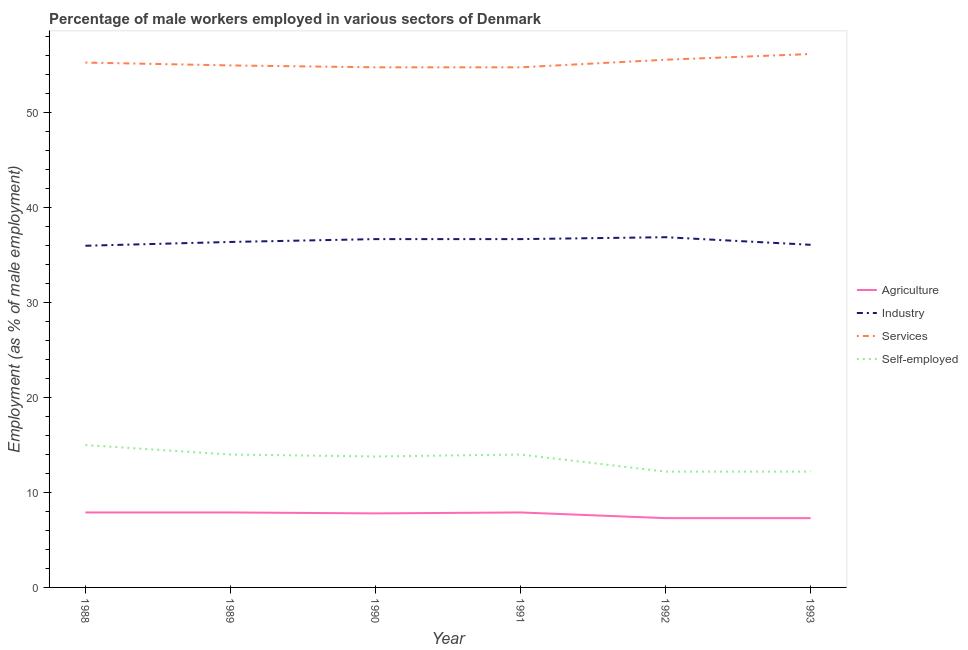Does the line corresponding to percentage of male workers in industry intersect with the line corresponding to percentage of self employed male workers?
Your answer should be very brief. No. What is the percentage of male workers in agriculture in 1993?
Your answer should be very brief. 7.3. Across all years, what is the maximum percentage of male workers in agriculture?
Provide a succinct answer. 7.9. Across all years, what is the minimum percentage of male workers in industry?
Ensure brevity in your answer.  36. In which year was the percentage of male workers in services maximum?
Provide a succinct answer. 1993. In which year was the percentage of male workers in agriculture minimum?
Your response must be concise. 1992. What is the total percentage of male workers in agriculture in the graph?
Your response must be concise. 46.1. What is the difference between the percentage of male workers in services in 1988 and that in 1991?
Offer a very short reply. 0.5. What is the difference between the percentage of male workers in services in 1992 and the percentage of self employed male workers in 1989?
Keep it short and to the point. 41.6. What is the average percentage of male workers in agriculture per year?
Your answer should be compact. 7.68. In the year 1992, what is the difference between the percentage of male workers in agriculture and percentage of male workers in industry?
Offer a terse response. -29.6. What is the ratio of the percentage of male workers in services in 1991 to that in 1992?
Your answer should be very brief. 0.99. Is the difference between the percentage of male workers in agriculture in 1989 and 1993 greater than the difference between the percentage of self employed male workers in 1989 and 1993?
Provide a succinct answer. No. What is the difference between the highest and the second highest percentage of male workers in agriculture?
Offer a very short reply. 0. What is the difference between the highest and the lowest percentage of male workers in agriculture?
Keep it short and to the point. 0.6. In how many years, is the percentage of male workers in industry greater than the average percentage of male workers in industry taken over all years?
Your answer should be compact. 3. Is it the case that in every year, the sum of the percentage of self employed male workers and percentage of male workers in agriculture is greater than the sum of percentage of male workers in services and percentage of male workers in industry?
Offer a terse response. No. Is it the case that in every year, the sum of the percentage of male workers in agriculture and percentage of male workers in industry is greater than the percentage of male workers in services?
Ensure brevity in your answer.  No. Is the percentage of male workers in agriculture strictly greater than the percentage of male workers in industry over the years?
Ensure brevity in your answer.  No. Is the percentage of male workers in industry strictly less than the percentage of male workers in agriculture over the years?
Ensure brevity in your answer.  No. How many years are there in the graph?
Give a very brief answer. 6. What is the difference between two consecutive major ticks on the Y-axis?
Your response must be concise. 10. Are the values on the major ticks of Y-axis written in scientific E-notation?
Offer a very short reply. No. Does the graph contain grids?
Provide a short and direct response. No. How are the legend labels stacked?
Your answer should be very brief. Vertical. What is the title of the graph?
Offer a terse response. Percentage of male workers employed in various sectors of Denmark. Does "Italy" appear as one of the legend labels in the graph?
Your answer should be compact. No. What is the label or title of the Y-axis?
Your response must be concise. Employment (as % of male employment). What is the Employment (as % of male employment) in Agriculture in 1988?
Your answer should be very brief. 7.9. What is the Employment (as % of male employment) of Industry in 1988?
Provide a succinct answer. 36. What is the Employment (as % of male employment) in Services in 1988?
Offer a terse response. 55.3. What is the Employment (as % of male employment) in Agriculture in 1989?
Provide a short and direct response. 7.9. What is the Employment (as % of male employment) of Industry in 1989?
Your answer should be compact. 36.4. What is the Employment (as % of male employment) of Services in 1989?
Your answer should be very brief. 55. What is the Employment (as % of male employment) in Self-employed in 1989?
Ensure brevity in your answer.  14. What is the Employment (as % of male employment) in Agriculture in 1990?
Your answer should be very brief. 7.8. What is the Employment (as % of male employment) in Industry in 1990?
Keep it short and to the point. 36.7. What is the Employment (as % of male employment) in Services in 1990?
Your answer should be very brief. 54.8. What is the Employment (as % of male employment) in Self-employed in 1990?
Give a very brief answer. 13.8. What is the Employment (as % of male employment) of Agriculture in 1991?
Your answer should be very brief. 7.9. What is the Employment (as % of male employment) in Industry in 1991?
Give a very brief answer. 36.7. What is the Employment (as % of male employment) of Services in 1991?
Keep it short and to the point. 54.8. What is the Employment (as % of male employment) of Self-employed in 1991?
Ensure brevity in your answer.  14. What is the Employment (as % of male employment) in Agriculture in 1992?
Offer a terse response. 7.3. What is the Employment (as % of male employment) in Industry in 1992?
Offer a very short reply. 36.9. What is the Employment (as % of male employment) of Services in 1992?
Provide a short and direct response. 55.6. What is the Employment (as % of male employment) of Self-employed in 1992?
Give a very brief answer. 12.2. What is the Employment (as % of male employment) in Agriculture in 1993?
Keep it short and to the point. 7.3. What is the Employment (as % of male employment) of Industry in 1993?
Provide a succinct answer. 36.1. What is the Employment (as % of male employment) in Services in 1993?
Make the answer very short. 56.2. What is the Employment (as % of male employment) of Self-employed in 1993?
Your answer should be compact. 12.2. Across all years, what is the maximum Employment (as % of male employment) in Agriculture?
Keep it short and to the point. 7.9. Across all years, what is the maximum Employment (as % of male employment) of Industry?
Provide a succinct answer. 36.9. Across all years, what is the maximum Employment (as % of male employment) in Services?
Make the answer very short. 56.2. Across all years, what is the maximum Employment (as % of male employment) in Self-employed?
Your answer should be very brief. 15. Across all years, what is the minimum Employment (as % of male employment) of Agriculture?
Offer a terse response. 7.3. Across all years, what is the minimum Employment (as % of male employment) in Services?
Give a very brief answer. 54.8. Across all years, what is the minimum Employment (as % of male employment) of Self-employed?
Your response must be concise. 12.2. What is the total Employment (as % of male employment) in Agriculture in the graph?
Offer a terse response. 46.1. What is the total Employment (as % of male employment) in Industry in the graph?
Make the answer very short. 218.8. What is the total Employment (as % of male employment) of Services in the graph?
Provide a succinct answer. 331.7. What is the total Employment (as % of male employment) of Self-employed in the graph?
Give a very brief answer. 81.2. What is the difference between the Employment (as % of male employment) in Industry in 1988 and that in 1989?
Provide a short and direct response. -0.4. What is the difference between the Employment (as % of male employment) of Self-employed in 1988 and that in 1989?
Offer a terse response. 1. What is the difference between the Employment (as % of male employment) of Agriculture in 1988 and that in 1991?
Offer a terse response. 0. What is the difference between the Employment (as % of male employment) in Services in 1988 and that in 1991?
Offer a terse response. 0.5. What is the difference between the Employment (as % of male employment) of Self-employed in 1988 and that in 1992?
Make the answer very short. 2.8. What is the difference between the Employment (as % of male employment) in Agriculture in 1988 and that in 1993?
Make the answer very short. 0.6. What is the difference between the Employment (as % of male employment) in Industry in 1988 and that in 1993?
Your response must be concise. -0.1. What is the difference between the Employment (as % of male employment) in Services in 1988 and that in 1993?
Keep it short and to the point. -0.9. What is the difference between the Employment (as % of male employment) in Self-employed in 1988 and that in 1993?
Provide a succinct answer. 2.8. What is the difference between the Employment (as % of male employment) of Agriculture in 1989 and that in 1990?
Give a very brief answer. 0.1. What is the difference between the Employment (as % of male employment) in Services in 1989 and that in 1990?
Provide a short and direct response. 0.2. What is the difference between the Employment (as % of male employment) of Industry in 1989 and that in 1991?
Your answer should be compact. -0.3. What is the difference between the Employment (as % of male employment) of Services in 1989 and that in 1991?
Your answer should be very brief. 0.2. What is the difference between the Employment (as % of male employment) of Agriculture in 1989 and that in 1992?
Make the answer very short. 0.6. What is the difference between the Employment (as % of male employment) in Services in 1989 and that in 1992?
Your answer should be very brief. -0.6. What is the difference between the Employment (as % of male employment) in Self-employed in 1989 and that in 1992?
Provide a short and direct response. 1.8. What is the difference between the Employment (as % of male employment) in Agriculture in 1989 and that in 1993?
Keep it short and to the point. 0.6. What is the difference between the Employment (as % of male employment) of Services in 1989 and that in 1993?
Make the answer very short. -1.2. What is the difference between the Employment (as % of male employment) of Industry in 1990 and that in 1991?
Provide a short and direct response. 0. What is the difference between the Employment (as % of male employment) in Services in 1990 and that in 1991?
Offer a very short reply. 0. What is the difference between the Employment (as % of male employment) in Self-employed in 1990 and that in 1991?
Your response must be concise. -0.2. What is the difference between the Employment (as % of male employment) in Industry in 1990 and that in 1992?
Provide a short and direct response. -0.2. What is the difference between the Employment (as % of male employment) in Services in 1990 and that in 1992?
Make the answer very short. -0.8. What is the difference between the Employment (as % of male employment) of Industry in 1990 and that in 1993?
Your answer should be very brief. 0.6. What is the difference between the Employment (as % of male employment) in Services in 1990 and that in 1993?
Provide a short and direct response. -1.4. What is the difference between the Employment (as % of male employment) in Agriculture in 1991 and that in 1992?
Ensure brevity in your answer.  0.6. What is the difference between the Employment (as % of male employment) of Self-employed in 1991 and that in 1992?
Make the answer very short. 1.8. What is the difference between the Employment (as % of male employment) of Self-employed in 1991 and that in 1993?
Your answer should be compact. 1.8. What is the difference between the Employment (as % of male employment) in Agriculture in 1992 and that in 1993?
Ensure brevity in your answer.  0. What is the difference between the Employment (as % of male employment) in Industry in 1992 and that in 1993?
Your answer should be compact. 0.8. What is the difference between the Employment (as % of male employment) in Services in 1992 and that in 1993?
Make the answer very short. -0.6. What is the difference between the Employment (as % of male employment) of Self-employed in 1992 and that in 1993?
Provide a short and direct response. 0. What is the difference between the Employment (as % of male employment) of Agriculture in 1988 and the Employment (as % of male employment) of Industry in 1989?
Offer a very short reply. -28.5. What is the difference between the Employment (as % of male employment) of Agriculture in 1988 and the Employment (as % of male employment) of Services in 1989?
Your response must be concise. -47.1. What is the difference between the Employment (as % of male employment) of Agriculture in 1988 and the Employment (as % of male employment) of Self-employed in 1989?
Provide a succinct answer. -6.1. What is the difference between the Employment (as % of male employment) in Services in 1988 and the Employment (as % of male employment) in Self-employed in 1989?
Your answer should be compact. 41.3. What is the difference between the Employment (as % of male employment) of Agriculture in 1988 and the Employment (as % of male employment) of Industry in 1990?
Ensure brevity in your answer.  -28.8. What is the difference between the Employment (as % of male employment) in Agriculture in 1988 and the Employment (as % of male employment) in Services in 1990?
Ensure brevity in your answer.  -46.9. What is the difference between the Employment (as % of male employment) in Industry in 1988 and the Employment (as % of male employment) in Services in 1990?
Offer a terse response. -18.8. What is the difference between the Employment (as % of male employment) of Industry in 1988 and the Employment (as % of male employment) of Self-employed in 1990?
Your answer should be compact. 22.2. What is the difference between the Employment (as % of male employment) in Services in 1988 and the Employment (as % of male employment) in Self-employed in 1990?
Your answer should be compact. 41.5. What is the difference between the Employment (as % of male employment) in Agriculture in 1988 and the Employment (as % of male employment) in Industry in 1991?
Keep it short and to the point. -28.8. What is the difference between the Employment (as % of male employment) in Agriculture in 1988 and the Employment (as % of male employment) in Services in 1991?
Keep it short and to the point. -46.9. What is the difference between the Employment (as % of male employment) of Agriculture in 1988 and the Employment (as % of male employment) of Self-employed in 1991?
Offer a terse response. -6.1. What is the difference between the Employment (as % of male employment) in Industry in 1988 and the Employment (as % of male employment) in Services in 1991?
Make the answer very short. -18.8. What is the difference between the Employment (as % of male employment) in Industry in 1988 and the Employment (as % of male employment) in Self-employed in 1991?
Provide a succinct answer. 22. What is the difference between the Employment (as % of male employment) of Services in 1988 and the Employment (as % of male employment) of Self-employed in 1991?
Keep it short and to the point. 41.3. What is the difference between the Employment (as % of male employment) of Agriculture in 1988 and the Employment (as % of male employment) of Industry in 1992?
Provide a succinct answer. -29. What is the difference between the Employment (as % of male employment) of Agriculture in 1988 and the Employment (as % of male employment) of Services in 1992?
Offer a terse response. -47.7. What is the difference between the Employment (as % of male employment) of Industry in 1988 and the Employment (as % of male employment) of Services in 1992?
Your answer should be compact. -19.6. What is the difference between the Employment (as % of male employment) in Industry in 1988 and the Employment (as % of male employment) in Self-employed in 1992?
Keep it short and to the point. 23.8. What is the difference between the Employment (as % of male employment) in Services in 1988 and the Employment (as % of male employment) in Self-employed in 1992?
Your answer should be compact. 43.1. What is the difference between the Employment (as % of male employment) of Agriculture in 1988 and the Employment (as % of male employment) of Industry in 1993?
Provide a succinct answer. -28.2. What is the difference between the Employment (as % of male employment) in Agriculture in 1988 and the Employment (as % of male employment) in Services in 1993?
Give a very brief answer. -48.3. What is the difference between the Employment (as % of male employment) in Agriculture in 1988 and the Employment (as % of male employment) in Self-employed in 1993?
Keep it short and to the point. -4.3. What is the difference between the Employment (as % of male employment) of Industry in 1988 and the Employment (as % of male employment) of Services in 1993?
Your response must be concise. -20.2. What is the difference between the Employment (as % of male employment) in Industry in 1988 and the Employment (as % of male employment) in Self-employed in 1993?
Your answer should be compact. 23.8. What is the difference between the Employment (as % of male employment) of Services in 1988 and the Employment (as % of male employment) of Self-employed in 1993?
Your response must be concise. 43.1. What is the difference between the Employment (as % of male employment) in Agriculture in 1989 and the Employment (as % of male employment) in Industry in 1990?
Make the answer very short. -28.8. What is the difference between the Employment (as % of male employment) of Agriculture in 1989 and the Employment (as % of male employment) of Services in 1990?
Keep it short and to the point. -46.9. What is the difference between the Employment (as % of male employment) in Agriculture in 1989 and the Employment (as % of male employment) in Self-employed in 1990?
Keep it short and to the point. -5.9. What is the difference between the Employment (as % of male employment) of Industry in 1989 and the Employment (as % of male employment) of Services in 1990?
Offer a terse response. -18.4. What is the difference between the Employment (as % of male employment) of Industry in 1989 and the Employment (as % of male employment) of Self-employed in 1990?
Your response must be concise. 22.6. What is the difference between the Employment (as % of male employment) in Services in 1989 and the Employment (as % of male employment) in Self-employed in 1990?
Make the answer very short. 41.2. What is the difference between the Employment (as % of male employment) in Agriculture in 1989 and the Employment (as % of male employment) in Industry in 1991?
Ensure brevity in your answer.  -28.8. What is the difference between the Employment (as % of male employment) in Agriculture in 1989 and the Employment (as % of male employment) in Services in 1991?
Provide a short and direct response. -46.9. What is the difference between the Employment (as % of male employment) of Agriculture in 1989 and the Employment (as % of male employment) of Self-employed in 1991?
Keep it short and to the point. -6.1. What is the difference between the Employment (as % of male employment) in Industry in 1989 and the Employment (as % of male employment) in Services in 1991?
Keep it short and to the point. -18.4. What is the difference between the Employment (as % of male employment) in Industry in 1989 and the Employment (as % of male employment) in Self-employed in 1991?
Your response must be concise. 22.4. What is the difference between the Employment (as % of male employment) of Services in 1989 and the Employment (as % of male employment) of Self-employed in 1991?
Keep it short and to the point. 41. What is the difference between the Employment (as % of male employment) of Agriculture in 1989 and the Employment (as % of male employment) of Services in 1992?
Your answer should be very brief. -47.7. What is the difference between the Employment (as % of male employment) of Agriculture in 1989 and the Employment (as % of male employment) of Self-employed in 1992?
Offer a very short reply. -4.3. What is the difference between the Employment (as % of male employment) of Industry in 1989 and the Employment (as % of male employment) of Services in 1992?
Keep it short and to the point. -19.2. What is the difference between the Employment (as % of male employment) of Industry in 1989 and the Employment (as % of male employment) of Self-employed in 1992?
Your answer should be compact. 24.2. What is the difference between the Employment (as % of male employment) in Services in 1989 and the Employment (as % of male employment) in Self-employed in 1992?
Offer a very short reply. 42.8. What is the difference between the Employment (as % of male employment) of Agriculture in 1989 and the Employment (as % of male employment) of Industry in 1993?
Provide a succinct answer. -28.2. What is the difference between the Employment (as % of male employment) in Agriculture in 1989 and the Employment (as % of male employment) in Services in 1993?
Provide a succinct answer. -48.3. What is the difference between the Employment (as % of male employment) in Agriculture in 1989 and the Employment (as % of male employment) in Self-employed in 1993?
Your answer should be very brief. -4.3. What is the difference between the Employment (as % of male employment) of Industry in 1989 and the Employment (as % of male employment) of Services in 1993?
Give a very brief answer. -19.8. What is the difference between the Employment (as % of male employment) of Industry in 1989 and the Employment (as % of male employment) of Self-employed in 1993?
Ensure brevity in your answer.  24.2. What is the difference between the Employment (as % of male employment) in Services in 1989 and the Employment (as % of male employment) in Self-employed in 1993?
Provide a succinct answer. 42.8. What is the difference between the Employment (as % of male employment) in Agriculture in 1990 and the Employment (as % of male employment) in Industry in 1991?
Ensure brevity in your answer.  -28.9. What is the difference between the Employment (as % of male employment) of Agriculture in 1990 and the Employment (as % of male employment) of Services in 1991?
Your answer should be compact. -47. What is the difference between the Employment (as % of male employment) of Agriculture in 1990 and the Employment (as % of male employment) of Self-employed in 1991?
Make the answer very short. -6.2. What is the difference between the Employment (as % of male employment) of Industry in 1990 and the Employment (as % of male employment) of Services in 1991?
Provide a short and direct response. -18.1. What is the difference between the Employment (as % of male employment) in Industry in 1990 and the Employment (as % of male employment) in Self-employed in 1991?
Provide a succinct answer. 22.7. What is the difference between the Employment (as % of male employment) in Services in 1990 and the Employment (as % of male employment) in Self-employed in 1991?
Offer a terse response. 40.8. What is the difference between the Employment (as % of male employment) in Agriculture in 1990 and the Employment (as % of male employment) in Industry in 1992?
Ensure brevity in your answer.  -29.1. What is the difference between the Employment (as % of male employment) in Agriculture in 1990 and the Employment (as % of male employment) in Services in 1992?
Make the answer very short. -47.8. What is the difference between the Employment (as % of male employment) in Agriculture in 1990 and the Employment (as % of male employment) in Self-employed in 1992?
Your answer should be very brief. -4.4. What is the difference between the Employment (as % of male employment) of Industry in 1990 and the Employment (as % of male employment) of Services in 1992?
Your answer should be compact. -18.9. What is the difference between the Employment (as % of male employment) in Industry in 1990 and the Employment (as % of male employment) in Self-employed in 1992?
Keep it short and to the point. 24.5. What is the difference between the Employment (as % of male employment) in Services in 1990 and the Employment (as % of male employment) in Self-employed in 1992?
Provide a succinct answer. 42.6. What is the difference between the Employment (as % of male employment) in Agriculture in 1990 and the Employment (as % of male employment) in Industry in 1993?
Provide a succinct answer. -28.3. What is the difference between the Employment (as % of male employment) in Agriculture in 1990 and the Employment (as % of male employment) in Services in 1993?
Make the answer very short. -48.4. What is the difference between the Employment (as % of male employment) in Industry in 1990 and the Employment (as % of male employment) in Services in 1993?
Give a very brief answer. -19.5. What is the difference between the Employment (as % of male employment) of Industry in 1990 and the Employment (as % of male employment) of Self-employed in 1993?
Your answer should be compact. 24.5. What is the difference between the Employment (as % of male employment) of Services in 1990 and the Employment (as % of male employment) of Self-employed in 1993?
Provide a succinct answer. 42.6. What is the difference between the Employment (as % of male employment) in Agriculture in 1991 and the Employment (as % of male employment) in Services in 1992?
Ensure brevity in your answer.  -47.7. What is the difference between the Employment (as % of male employment) in Industry in 1991 and the Employment (as % of male employment) in Services in 1992?
Provide a succinct answer. -18.9. What is the difference between the Employment (as % of male employment) in Industry in 1991 and the Employment (as % of male employment) in Self-employed in 1992?
Your answer should be compact. 24.5. What is the difference between the Employment (as % of male employment) in Services in 1991 and the Employment (as % of male employment) in Self-employed in 1992?
Keep it short and to the point. 42.6. What is the difference between the Employment (as % of male employment) in Agriculture in 1991 and the Employment (as % of male employment) in Industry in 1993?
Your answer should be very brief. -28.2. What is the difference between the Employment (as % of male employment) of Agriculture in 1991 and the Employment (as % of male employment) of Services in 1993?
Provide a short and direct response. -48.3. What is the difference between the Employment (as % of male employment) of Agriculture in 1991 and the Employment (as % of male employment) of Self-employed in 1993?
Your response must be concise. -4.3. What is the difference between the Employment (as % of male employment) of Industry in 1991 and the Employment (as % of male employment) of Services in 1993?
Your answer should be very brief. -19.5. What is the difference between the Employment (as % of male employment) in Services in 1991 and the Employment (as % of male employment) in Self-employed in 1993?
Ensure brevity in your answer.  42.6. What is the difference between the Employment (as % of male employment) in Agriculture in 1992 and the Employment (as % of male employment) in Industry in 1993?
Offer a terse response. -28.8. What is the difference between the Employment (as % of male employment) in Agriculture in 1992 and the Employment (as % of male employment) in Services in 1993?
Your answer should be compact. -48.9. What is the difference between the Employment (as % of male employment) of Agriculture in 1992 and the Employment (as % of male employment) of Self-employed in 1993?
Your response must be concise. -4.9. What is the difference between the Employment (as % of male employment) in Industry in 1992 and the Employment (as % of male employment) in Services in 1993?
Ensure brevity in your answer.  -19.3. What is the difference between the Employment (as % of male employment) of Industry in 1992 and the Employment (as % of male employment) of Self-employed in 1993?
Keep it short and to the point. 24.7. What is the difference between the Employment (as % of male employment) of Services in 1992 and the Employment (as % of male employment) of Self-employed in 1993?
Provide a short and direct response. 43.4. What is the average Employment (as % of male employment) in Agriculture per year?
Your answer should be very brief. 7.68. What is the average Employment (as % of male employment) in Industry per year?
Your answer should be compact. 36.47. What is the average Employment (as % of male employment) of Services per year?
Your answer should be compact. 55.28. What is the average Employment (as % of male employment) of Self-employed per year?
Ensure brevity in your answer.  13.53. In the year 1988, what is the difference between the Employment (as % of male employment) of Agriculture and Employment (as % of male employment) of Industry?
Provide a short and direct response. -28.1. In the year 1988, what is the difference between the Employment (as % of male employment) of Agriculture and Employment (as % of male employment) of Services?
Provide a succinct answer. -47.4. In the year 1988, what is the difference between the Employment (as % of male employment) of Agriculture and Employment (as % of male employment) of Self-employed?
Offer a very short reply. -7.1. In the year 1988, what is the difference between the Employment (as % of male employment) in Industry and Employment (as % of male employment) in Services?
Your answer should be compact. -19.3. In the year 1988, what is the difference between the Employment (as % of male employment) of Industry and Employment (as % of male employment) of Self-employed?
Offer a terse response. 21. In the year 1988, what is the difference between the Employment (as % of male employment) of Services and Employment (as % of male employment) of Self-employed?
Give a very brief answer. 40.3. In the year 1989, what is the difference between the Employment (as % of male employment) of Agriculture and Employment (as % of male employment) of Industry?
Your answer should be very brief. -28.5. In the year 1989, what is the difference between the Employment (as % of male employment) of Agriculture and Employment (as % of male employment) of Services?
Provide a succinct answer. -47.1. In the year 1989, what is the difference between the Employment (as % of male employment) of Agriculture and Employment (as % of male employment) of Self-employed?
Your response must be concise. -6.1. In the year 1989, what is the difference between the Employment (as % of male employment) in Industry and Employment (as % of male employment) in Services?
Provide a succinct answer. -18.6. In the year 1989, what is the difference between the Employment (as % of male employment) of Industry and Employment (as % of male employment) of Self-employed?
Keep it short and to the point. 22.4. In the year 1990, what is the difference between the Employment (as % of male employment) of Agriculture and Employment (as % of male employment) of Industry?
Your answer should be compact. -28.9. In the year 1990, what is the difference between the Employment (as % of male employment) of Agriculture and Employment (as % of male employment) of Services?
Your response must be concise. -47. In the year 1990, what is the difference between the Employment (as % of male employment) in Agriculture and Employment (as % of male employment) in Self-employed?
Offer a terse response. -6. In the year 1990, what is the difference between the Employment (as % of male employment) in Industry and Employment (as % of male employment) in Services?
Keep it short and to the point. -18.1. In the year 1990, what is the difference between the Employment (as % of male employment) of Industry and Employment (as % of male employment) of Self-employed?
Make the answer very short. 22.9. In the year 1991, what is the difference between the Employment (as % of male employment) in Agriculture and Employment (as % of male employment) in Industry?
Your answer should be compact. -28.8. In the year 1991, what is the difference between the Employment (as % of male employment) of Agriculture and Employment (as % of male employment) of Services?
Offer a very short reply. -46.9. In the year 1991, what is the difference between the Employment (as % of male employment) in Industry and Employment (as % of male employment) in Services?
Give a very brief answer. -18.1. In the year 1991, what is the difference between the Employment (as % of male employment) of Industry and Employment (as % of male employment) of Self-employed?
Ensure brevity in your answer.  22.7. In the year 1991, what is the difference between the Employment (as % of male employment) of Services and Employment (as % of male employment) of Self-employed?
Your response must be concise. 40.8. In the year 1992, what is the difference between the Employment (as % of male employment) of Agriculture and Employment (as % of male employment) of Industry?
Your answer should be compact. -29.6. In the year 1992, what is the difference between the Employment (as % of male employment) in Agriculture and Employment (as % of male employment) in Services?
Ensure brevity in your answer.  -48.3. In the year 1992, what is the difference between the Employment (as % of male employment) in Industry and Employment (as % of male employment) in Services?
Your answer should be very brief. -18.7. In the year 1992, what is the difference between the Employment (as % of male employment) in Industry and Employment (as % of male employment) in Self-employed?
Your response must be concise. 24.7. In the year 1992, what is the difference between the Employment (as % of male employment) in Services and Employment (as % of male employment) in Self-employed?
Provide a short and direct response. 43.4. In the year 1993, what is the difference between the Employment (as % of male employment) of Agriculture and Employment (as % of male employment) of Industry?
Offer a terse response. -28.8. In the year 1993, what is the difference between the Employment (as % of male employment) in Agriculture and Employment (as % of male employment) in Services?
Keep it short and to the point. -48.9. In the year 1993, what is the difference between the Employment (as % of male employment) of Agriculture and Employment (as % of male employment) of Self-employed?
Your response must be concise. -4.9. In the year 1993, what is the difference between the Employment (as % of male employment) in Industry and Employment (as % of male employment) in Services?
Offer a terse response. -20.1. In the year 1993, what is the difference between the Employment (as % of male employment) in Industry and Employment (as % of male employment) in Self-employed?
Ensure brevity in your answer.  23.9. In the year 1993, what is the difference between the Employment (as % of male employment) in Services and Employment (as % of male employment) in Self-employed?
Offer a terse response. 44. What is the ratio of the Employment (as % of male employment) in Industry in 1988 to that in 1989?
Your answer should be very brief. 0.99. What is the ratio of the Employment (as % of male employment) in Services in 1988 to that in 1989?
Your answer should be compact. 1.01. What is the ratio of the Employment (as % of male employment) in Self-employed in 1988 to that in 1989?
Your response must be concise. 1.07. What is the ratio of the Employment (as % of male employment) in Agriculture in 1988 to that in 1990?
Offer a terse response. 1.01. What is the ratio of the Employment (as % of male employment) of Industry in 1988 to that in 1990?
Your answer should be compact. 0.98. What is the ratio of the Employment (as % of male employment) of Services in 1988 to that in 1990?
Offer a terse response. 1.01. What is the ratio of the Employment (as % of male employment) in Self-employed in 1988 to that in 1990?
Provide a succinct answer. 1.09. What is the ratio of the Employment (as % of male employment) in Agriculture in 1988 to that in 1991?
Give a very brief answer. 1. What is the ratio of the Employment (as % of male employment) in Industry in 1988 to that in 1991?
Provide a succinct answer. 0.98. What is the ratio of the Employment (as % of male employment) in Services in 1988 to that in 1991?
Give a very brief answer. 1.01. What is the ratio of the Employment (as % of male employment) in Self-employed in 1988 to that in 1991?
Your response must be concise. 1.07. What is the ratio of the Employment (as % of male employment) in Agriculture in 1988 to that in 1992?
Your answer should be very brief. 1.08. What is the ratio of the Employment (as % of male employment) of Industry in 1988 to that in 1992?
Give a very brief answer. 0.98. What is the ratio of the Employment (as % of male employment) in Self-employed in 1988 to that in 1992?
Make the answer very short. 1.23. What is the ratio of the Employment (as % of male employment) in Agriculture in 1988 to that in 1993?
Provide a short and direct response. 1.08. What is the ratio of the Employment (as % of male employment) in Self-employed in 1988 to that in 1993?
Keep it short and to the point. 1.23. What is the ratio of the Employment (as % of male employment) in Agriculture in 1989 to that in 1990?
Keep it short and to the point. 1.01. What is the ratio of the Employment (as % of male employment) in Services in 1989 to that in 1990?
Keep it short and to the point. 1. What is the ratio of the Employment (as % of male employment) of Self-employed in 1989 to that in 1990?
Your response must be concise. 1.01. What is the ratio of the Employment (as % of male employment) of Self-employed in 1989 to that in 1991?
Your response must be concise. 1. What is the ratio of the Employment (as % of male employment) of Agriculture in 1989 to that in 1992?
Make the answer very short. 1.08. What is the ratio of the Employment (as % of male employment) in Industry in 1989 to that in 1992?
Ensure brevity in your answer.  0.99. What is the ratio of the Employment (as % of male employment) of Services in 1989 to that in 1992?
Offer a very short reply. 0.99. What is the ratio of the Employment (as % of male employment) in Self-employed in 1989 to that in 1992?
Ensure brevity in your answer.  1.15. What is the ratio of the Employment (as % of male employment) in Agriculture in 1989 to that in 1993?
Your response must be concise. 1.08. What is the ratio of the Employment (as % of male employment) in Industry in 1989 to that in 1993?
Offer a very short reply. 1.01. What is the ratio of the Employment (as % of male employment) in Services in 1989 to that in 1993?
Your answer should be compact. 0.98. What is the ratio of the Employment (as % of male employment) in Self-employed in 1989 to that in 1993?
Ensure brevity in your answer.  1.15. What is the ratio of the Employment (as % of male employment) in Agriculture in 1990 to that in 1991?
Offer a terse response. 0.99. What is the ratio of the Employment (as % of male employment) in Industry in 1990 to that in 1991?
Keep it short and to the point. 1. What is the ratio of the Employment (as % of male employment) of Self-employed in 1990 to that in 1991?
Ensure brevity in your answer.  0.99. What is the ratio of the Employment (as % of male employment) in Agriculture in 1990 to that in 1992?
Provide a succinct answer. 1.07. What is the ratio of the Employment (as % of male employment) in Industry in 1990 to that in 1992?
Your response must be concise. 0.99. What is the ratio of the Employment (as % of male employment) of Services in 1990 to that in 1992?
Make the answer very short. 0.99. What is the ratio of the Employment (as % of male employment) of Self-employed in 1990 to that in 1992?
Ensure brevity in your answer.  1.13. What is the ratio of the Employment (as % of male employment) in Agriculture in 1990 to that in 1993?
Provide a short and direct response. 1.07. What is the ratio of the Employment (as % of male employment) of Industry in 1990 to that in 1993?
Provide a succinct answer. 1.02. What is the ratio of the Employment (as % of male employment) of Services in 1990 to that in 1993?
Your answer should be compact. 0.98. What is the ratio of the Employment (as % of male employment) in Self-employed in 1990 to that in 1993?
Your answer should be very brief. 1.13. What is the ratio of the Employment (as % of male employment) in Agriculture in 1991 to that in 1992?
Your answer should be very brief. 1.08. What is the ratio of the Employment (as % of male employment) in Services in 1991 to that in 1992?
Provide a succinct answer. 0.99. What is the ratio of the Employment (as % of male employment) in Self-employed in 1991 to that in 1992?
Provide a succinct answer. 1.15. What is the ratio of the Employment (as % of male employment) in Agriculture in 1991 to that in 1993?
Your response must be concise. 1.08. What is the ratio of the Employment (as % of male employment) in Industry in 1991 to that in 1993?
Give a very brief answer. 1.02. What is the ratio of the Employment (as % of male employment) in Services in 1991 to that in 1993?
Provide a succinct answer. 0.98. What is the ratio of the Employment (as % of male employment) of Self-employed in 1991 to that in 1993?
Your answer should be compact. 1.15. What is the ratio of the Employment (as % of male employment) of Agriculture in 1992 to that in 1993?
Offer a terse response. 1. What is the ratio of the Employment (as % of male employment) in Industry in 1992 to that in 1993?
Offer a terse response. 1.02. What is the ratio of the Employment (as % of male employment) in Services in 1992 to that in 1993?
Give a very brief answer. 0.99. What is the ratio of the Employment (as % of male employment) of Self-employed in 1992 to that in 1993?
Provide a succinct answer. 1. What is the difference between the highest and the second highest Employment (as % of male employment) in Agriculture?
Make the answer very short. 0. What is the difference between the highest and the second highest Employment (as % of male employment) in Industry?
Your answer should be very brief. 0.2. What is the difference between the highest and the lowest Employment (as % of male employment) in Industry?
Your answer should be compact. 0.9. 